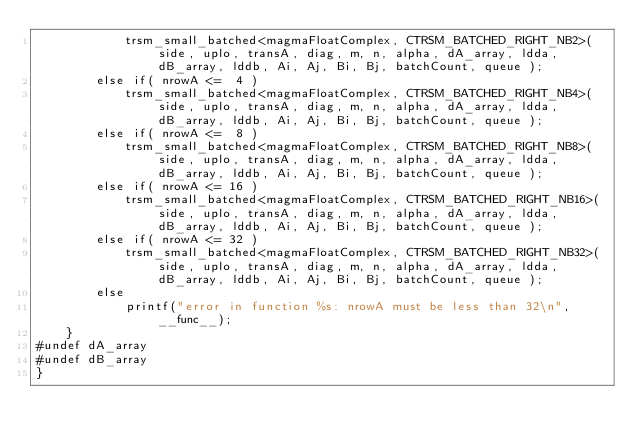Convert code to text. <code><loc_0><loc_0><loc_500><loc_500><_Cuda_>            trsm_small_batched<magmaFloatComplex, CTRSM_BATCHED_RIGHT_NB2>(side, uplo, transA, diag, m, n, alpha, dA_array, ldda, dB_array, lddb, Ai, Aj, Bi, Bj, batchCount, queue );
        else if( nrowA <=  4 )
            trsm_small_batched<magmaFloatComplex, CTRSM_BATCHED_RIGHT_NB4>(side, uplo, transA, diag, m, n, alpha, dA_array, ldda, dB_array, lddb, Ai, Aj, Bi, Bj, batchCount, queue );
        else if( nrowA <=  8 )
            trsm_small_batched<magmaFloatComplex, CTRSM_BATCHED_RIGHT_NB8>(side, uplo, transA, diag, m, n, alpha, dA_array, ldda, dB_array, lddb, Ai, Aj, Bi, Bj, batchCount, queue );
        else if( nrowA <= 16 )
            trsm_small_batched<magmaFloatComplex, CTRSM_BATCHED_RIGHT_NB16>(side, uplo, transA, diag, m, n, alpha, dA_array, ldda, dB_array, lddb, Ai, Aj, Bi, Bj, batchCount, queue );
        else if( nrowA <= 32 )
            trsm_small_batched<magmaFloatComplex, CTRSM_BATCHED_RIGHT_NB32>(side, uplo, transA, diag, m, n, alpha, dA_array, ldda, dB_array, lddb, Ai, Aj, Bi, Bj, batchCount, queue );
        else
            printf("error in function %s: nrowA must be less than 32\n", __func__);
    }
#undef dA_array
#undef dB_array
}

</code> 